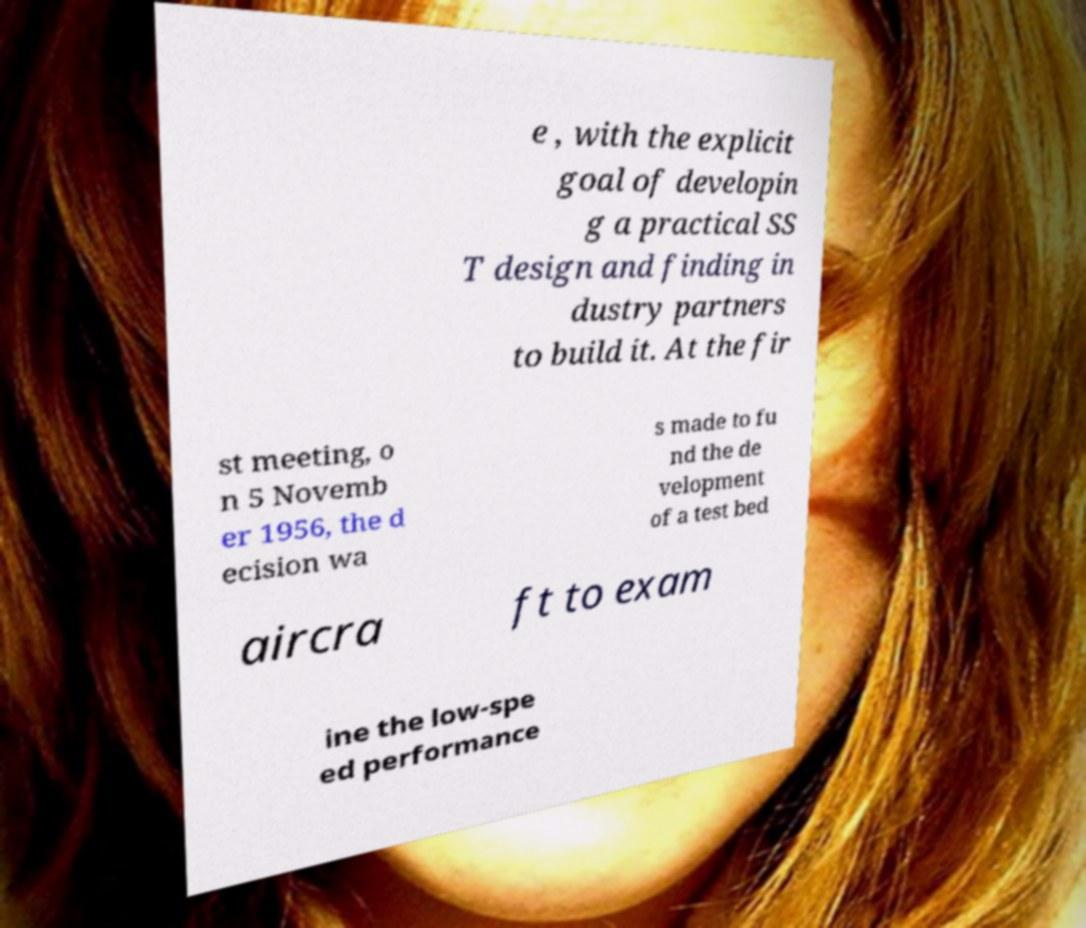There's text embedded in this image that I need extracted. Can you transcribe it verbatim? e , with the explicit goal of developin g a practical SS T design and finding in dustry partners to build it. At the fir st meeting, o n 5 Novemb er 1956, the d ecision wa s made to fu nd the de velopment of a test bed aircra ft to exam ine the low-spe ed performance 